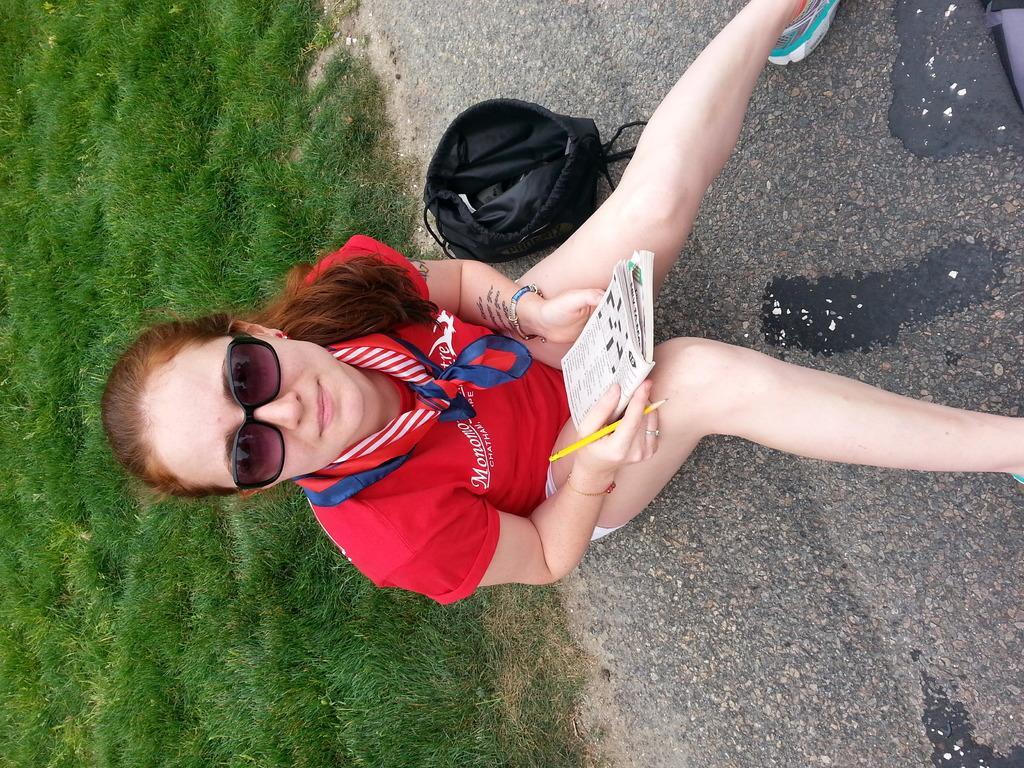Could you give a brief overview of what you see in this image? In this image in the center there is one woman who is sitting and she is holding a book and a pen, beside her there is one bag. On the left side there is grass, on the right side there is a walkway. 